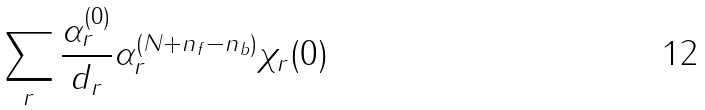<formula> <loc_0><loc_0><loc_500><loc_500>\sum _ { r } \frac { \alpha _ { r } ^ { ( 0 ) } } { d _ { r } } \alpha _ { r } ^ { ( N + n _ { f } - n _ { b } ) } \chi _ { r } ( 0 )</formula> 